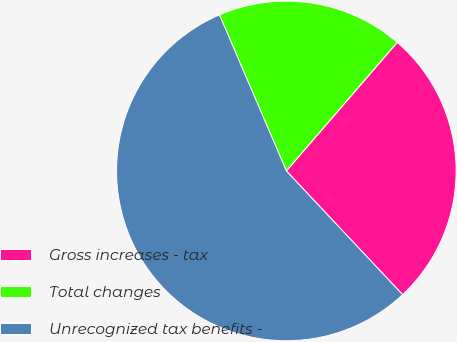Convert chart to OTSL. <chart><loc_0><loc_0><loc_500><loc_500><pie_chart><fcel>Gross increases - tax<fcel>Total changes<fcel>Unrecognized tax benefits -<nl><fcel>26.67%<fcel>17.78%<fcel>55.56%<nl></chart> 